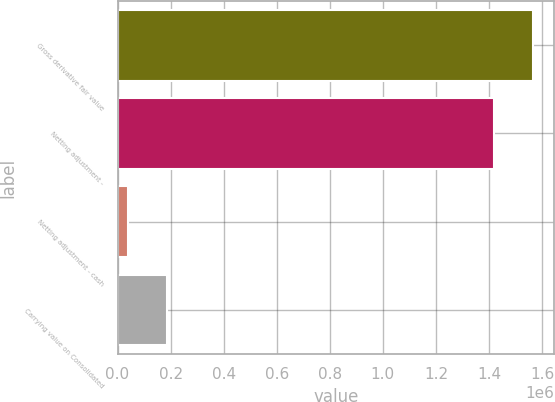Convert chart. <chart><loc_0><loc_0><loc_500><loc_500><bar_chart><fcel>Gross derivative fair value<fcel>Netting adjustment -<fcel>Netting adjustment - cash<fcel>Carrying value on Consolidated<nl><fcel>1.56784e+06<fcel>1.41984e+06<fcel>39218<fcel>187214<nl></chart> 